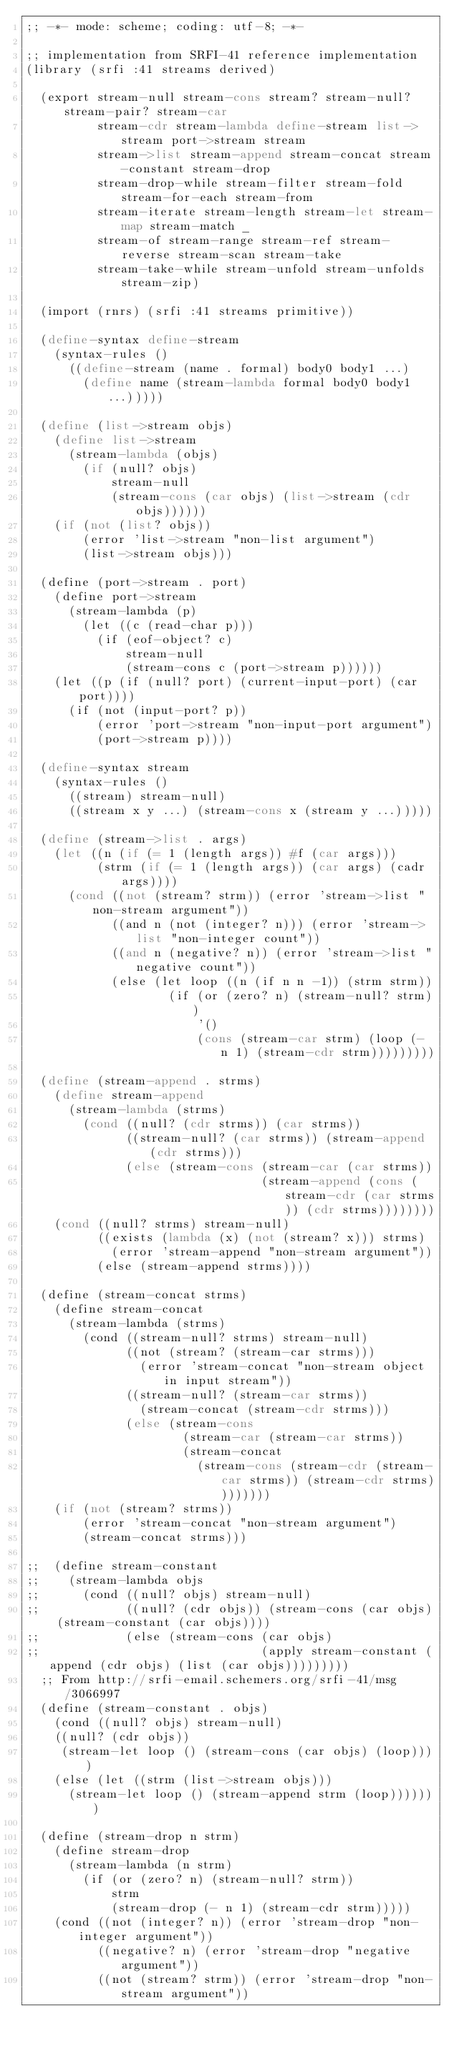Convert code to text. <code><loc_0><loc_0><loc_500><loc_500><_Scheme_>;; -*- mode: scheme; coding: utf-8; -*-

;; implementation from SRFI-41 reference implementation
(library (srfi :41 streams derived)

  (export stream-null stream-cons stream? stream-null? stream-pair? stream-car
          stream-cdr stream-lambda define-stream list->stream port->stream stream
          stream->list stream-append stream-concat stream-constant stream-drop
          stream-drop-while stream-filter stream-fold stream-for-each stream-from
          stream-iterate stream-length stream-let stream-map stream-match _
          stream-of stream-range stream-ref stream-reverse stream-scan stream-take
          stream-take-while stream-unfold stream-unfolds stream-zip)

  (import (rnrs) (srfi :41 streams primitive))

  (define-syntax define-stream
    (syntax-rules ()
      ((define-stream (name . formal) body0 body1 ...)
        (define name (stream-lambda formal body0 body1 ...)))))

  (define (list->stream objs)
    (define list->stream
      (stream-lambda (objs)
        (if (null? objs)
            stream-null
            (stream-cons (car objs) (list->stream (cdr objs))))))
    (if (not (list? objs))
        (error 'list->stream "non-list argument")
        (list->stream objs)))

  (define (port->stream . port)
    (define port->stream
      (stream-lambda (p)
        (let ((c (read-char p)))
          (if (eof-object? c)
              stream-null
              (stream-cons c (port->stream p))))))
    (let ((p (if (null? port) (current-input-port) (car port))))
      (if (not (input-port? p))
          (error 'port->stream "non-input-port argument")
          (port->stream p))))

  (define-syntax stream
    (syntax-rules ()
      ((stream) stream-null)
      ((stream x y ...) (stream-cons x (stream y ...)))))

  (define (stream->list . args)
    (let ((n (if (= 1 (length args)) #f (car args)))
          (strm (if (= 1 (length args)) (car args) (cadr args))))
      (cond ((not (stream? strm)) (error 'stream->list "non-stream argument"))
            ((and n (not (integer? n))) (error 'stream->list "non-integer count"))
            ((and n (negative? n)) (error 'stream->list "negative count"))
            (else (let loop ((n (if n n -1)) (strm strm))
                    (if (or (zero? n) (stream-null? strm))
                        '()
                        (cons (stream-car strm) (loop (- n 1) (stream-cdr strm)))))))))

  (define (stream-append . strms)
    (define stream-append
      (stream-lambda (strms)
        (cond ((null? (cdr strms)) (car strms))
              ((stream-null? (car strms)) (stream-append (cdr strms)))
              (else (stream-cons (stream-car (car strms))
                                 (stream-append (cons (stream-cdr (car strms)) (cdr strms))))))))
    (cond ((null? strms) stream-null)
          ((exists (lambda (x) (not (stream? x))) strms)
            (error 'stream-append "non-stream argument"))
          (else (stream-append strms))))

  (define (stream-concat strms)
    (define stream-concat
      (stream-lambda (strms)
        (cond ((stream-null? strms) stream-null)
              ((not (stream? (stream-car strms)))
                (error 'stream-concat "non-stream object in input stream"))
              ((stream-null? (stream-car strms))
                (stream-concat (stream-cdr strms)))
              (else (stream-cons
                      (stream-car (stream-car strms))
                      (stream-concat
                        (stream-cons (stream-cdr (stream-car strms)) (stream-cdr strms))))))))
    (if (not (stream? strms))
        (error 'stream-concat "non-stream argument")
        (stream-concat strms)))

;;  (define stream-constant
;;    (stream-lambda objs
;;      (cond ((null? objs) stream-null)
;;            ((null? (cdr objs)) (stream-cons (car objs) (stream-constant (car objs))))
;;            (else (stream-cons (car objs)
;;                               (apply stream-constant (append (cdr objs) (list (car objs)))))))))
  ;; From http://srfi-email.schemers.org/srfi-41/msg/3066997
  (define (stream-constant . objs)
    (cond ((null? objs) stream-null)
	  ((null? (cdr objs)) 
	   (stream-let loop () (stream-cons (car objs) (loop))))
	  (else (let ((strm (list->stream objs)))
		  (stream-let loop () (stream-append strm (loop)))))))

  (define (stream-drop n strm)
    (define stream-drop
      (stream-lambda (n strm)
        (if (or (zero? n) (stream-null? strm))
            strm
            (stream-drop (- n 1) (stream-cdr strm)))))
    (cond ((not (integer? n)) (error 'stream-drop "non-integer argument"))
          ((negative? n) (error 'stream-drop "negative argument"))
          ((not (stream? strm)) (error 'stream-drop "non-stream argument"))</code> 